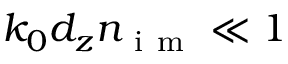<formula> <loc_0><loc_0><loc_500><loc_500>k _ { 0 } d _ { z } n _ { i m } \ll 1</formula> 